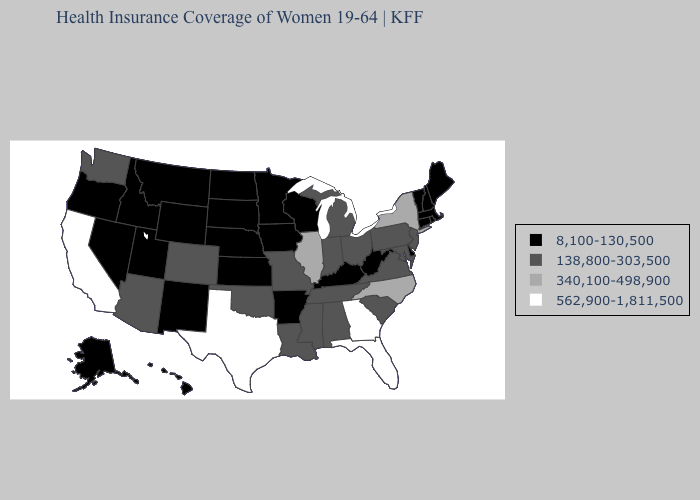What is the value of Florida?
Be succinct. 562,900-1,811,500. Does Vermont have the lowest value in the USA?
Keep it brief. Yes. Name the states that have a value in the range 562,900-1,811,500?
Quick response, please. California, Florida, Georgia, Texas. What is the highest value in states that border Ohio?
Quick response, please. 138,800-303,500. What is the highest value in the USA?
Give a very brief answer. 562,900-1,811,500. What is the value of North Carolina?
Give a very brief answer. 340,100-498,900. Does the map have missing data?
Write a very short answer. No. What is the value of North Dakota?
Keep it brief. 8,100-130,500. Name the states that have a value in the range 562,900-1,811,500?
Quick response, please. California, Florida, Georgia, Texas. Does Washington have the lowest value in the West?
Answer briefly. No. Does Colorado have the lowest value in the USA?
Write a very short answer. No. What is the lowest value in the West?
Keep it brief. 8,100-130,500. Does the map have missing data?
Write a very short answer. No. Which states have the highest value in the USA?
Be succinct. California, Florida, Georgia, Texas. 